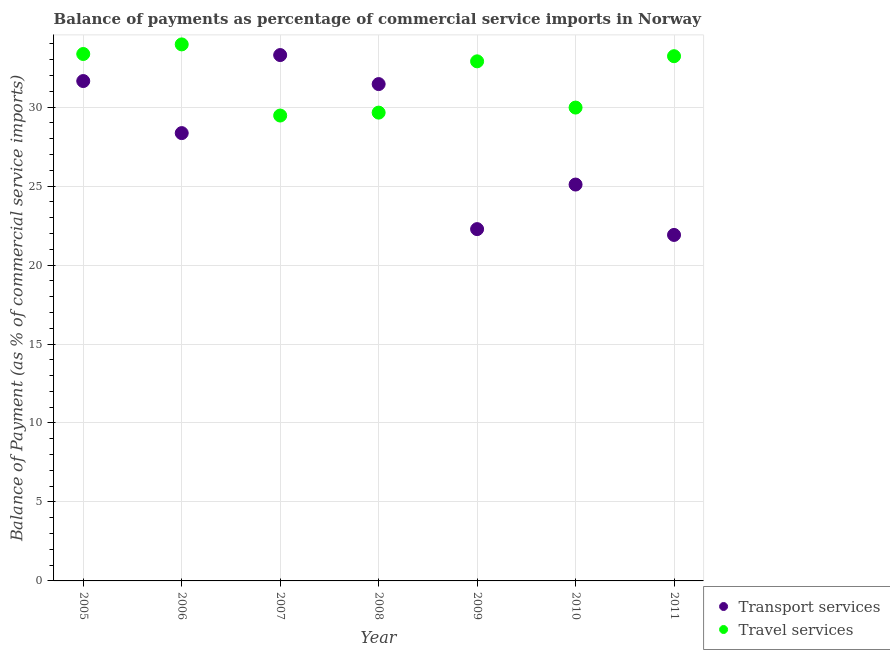How many different coloured dotlines are there?
Provide a succinct answer. 2. What is the balance of payments of transport services in 2008?
Your answer should be compact. 31.46. Across all years, what is the maximum balance of payments of travel services?
Your answer should be compact. 33.97. Across all years, what is the minimum balance of payments of travel services?
Ensure brevity in your answer.  29.47. In which year was the balance of payments of travel services minimum?
Your answer should be compact. 2007. What is the total balance of payments of travel services in the graph?
Your response must be concise. 222.55. What is the difference between the balance of payments of travel services in 2010 and that in 2011?
Ensure brevity in your answer.  -3.25. What is the difference between the balance of payments of travel services in 2010 and the balance of payments of transport services in 2005?
Give a very brief answer. -1.68. What is the average balance of payments of transport services per year?
Offer a terse response. 27.72. In the year 2006, what is the difference between the balance of payments of travel services and balance of payments of transport services?
Offer a very short reply. 5.62. In how many years, is the balance of payments of travel services greater than 12 %?
Provide a succinct answer. 7. What is the ratio of the balance of payments of travel services in 2007 to that in 2008?
Provide a short and direct response. 0.99. What is the difference between the highest and the second highest balance of payments of travel services?
Your response must be concise. 0.61. What is the difference between the highest and the lowest balance of payments of travel services?
Provide a short and direct response. 4.5. In how many years, is the balance of payments of travel services greater than the average balance of payments of travel services taken over all years?
Your answer should be compact. 4. Does the graph contain grids?
Your response must be concise. Yes. How many legend labels are there?
Give a very brief answer. 2. How are the legend labels stacked?
Your response must be concise. Vertical. What is the title of the graph?
Offer a terse response. Balance of payments as percentage of commercial service imports in Norway. Does "Infant" appear as one of the legend labels in the graph?
Ensure brevity in your answer.  No. What is the label or title of the X-axis?
Provide a short and direct response. Year. What is the label or title of the Y-axis?
Your answer should be compact. Balance of Payment (as % of commercial service imports). What is the Balance of Payment (as % of commercial service imports) in Transport services in 2005?
Give a very brief answer. 31.65. What is the Balance of Payment (as % of commercial service imports) of Travel services in 2005?
Make the answer very short. 33.36. What is the Balance of Payment (as % of commercial service imports) of Transport services in 2006?
Ensure brevity in your answer.  28.35. What is the Balance of Payment (as % of commercial service imports) of Travel services in 2006?
Keep it short and to the point. 33.97. What is the Balance of Payment (as % of commercial service imports) in Transport services in 2007?
Keep it short and to the point. 33.3. What is the Balance of Payment (as % of commercial service imports) in Travel services in 2007?
Keep it short and to the point. 29.47. What is the Balance of Payment (as % of commercial service imports) of Transport services in 2008?
Your answer should be very brief. 31.46. What is the Balance of Payment (as % of commercial service imports) of Travel services in 2008?
Offer a very short reply. 29.65. What is the Balance of Payment (as % of commercial service imports) in Transport services in 2009?
Your response must be concise. 22.28. What is the Balance of Payment (as % of commercial service imports) of Travel services in 2009?
Give a very brief answer. 32.9. What is the Balance of Payment (as % of commercial service imports) of Transport services in 2010?
Provide a short and direct response. 25.1. What is the Balance of Payment (as % of commercial service imports) in Travel services in 2010?
Keep it short and to the point. 29.97. What is the Balance of Payment (as % of commercial service imports) of Transport services in 2011?
Offer a terse response. 21.91. What is the Balance of Payment (as % of commercial service imports) of Travel services in 2011?
Your response must be concise. 33.22. Across all years, what is the maximum Balance of Payment (as % of commercial service imports) in Transport services?
Keep it short and to the point. 33.3. Across all years, what is the maximum Balance of Payment (as % of commercial service imports) in Travel services?
Offer a terse response. 33.97. Across all years, what is the minimum Balance of Payment (as % of commercial service imports) of Transport services?
Offer a very short reply. 21.91. Across all years, what is the minimum Balance of Payment (as % of commercial service imports) in Travel services?
Your answer should be very brief. 29.47. What is the total Balance of Payment (as % of commercial service imports) in Transport services in the graph?
Your answer should be very brief. 194.04. What is the total Balance of Payment (as % of commercial service imports) in Travel services in the graph?
Offer a very short reply. 222.55. What is the difference between the Balance of Payment (as % of commercial service imports) in Transport services in 2005 and that in 2006?
Provide a succinct answer. 3.3. What is the difference between the Balance of Payment (as % of commercial service imports) of Travel services in 2005 and that in 2006?
Make the answer very short. -0.61. What is the difference between the Balance of Payment (as % of commercial service imports) of Transport services in 2005 and that in 2007?
Provide a short and direct response. -1.65. What is the difference between the Balance of Payment (as % of commercial service imports) in Travel services in 2005 and that in 2007?
Your answer should be very brief. 3.9. What is the difference between the Balance of Payment (as % of commercial service imports) of Transport services in 2005 and that in 2008?
Your response must be concise. 0.19. What is the difference between the Balance of Payment (as % of commercial service imports) in Travel services in 2005 and that in 2008?
Ensure brevity in your answer.  3.71. What is the difference between the Balance of Payment (as % of commercial service imports) of Transport services in 2005 and that in 2009?
Offer a terse response. 9.38. What is the difference between the Balance of Payment (as % of commercial service imports) of Travel services in 2005 and that in 2009?
Keep it short and to the point. 0.46. What is the difference between the Balance of Payment (as % of commercial service imports) in Transport services in 2005 and that in 2010?
Ensure brevity in your answer.  6.55. What is the difference between the Balance of Payment (as % of commercial service imports) in Travel services in 2005 and that in 2010?
Ensure brevity in your answer.  3.39. What is the difference between the Balance of Payment (as % of commercial service imports) of Transport services in 2005 and that in 2011?
Your answer should be very brief. 9.74. What is the difference between the Balance of Payment (as % of commercial service imports) of Travel services in 2005 and that in 2011?
Provide a short and direct response. 0.14. What is the difference between the Balance of Payment (as % of commercial service imports) in Transport services in 2006 and that in 2007?
Offer a very short reply. -4.94. What is the difference between the Balance of Payment (as % of commercial service imports) in Travel services in 2006 and that in 2007?
Provide a succinct answer. 4.5. What is the difference between the Balance of Payment (as % of commercial service imports) in Transport services in 2006 and that in 2008?
Give a very brief answer. -3.1. What is the difference between the Balance of Payment (as % of commercial service imports) of Travel services in 2006 and that in 2008?
Keep it short and to the point. 4.32. What is the difference between the Balance of Payment (as % of commercial service imports) in Transport services in 2006 and that in 2009?
Keep it short and to the point. 6.08. What is the difference between the Balance of Payment (as % of commercial service imports) in Travel services in 2006 and that in 2009?
Provide a succinct answer. 1.07. What is the difference between the Balance of Payment (as % of commercial service imports) in Transport services in 2006 and that in 2010?
Your answer should be very brief. 3.26. What is the difference between the Balance of Payment (as % of commercial service imports) in Travel services in 2006 and that in 2010?
Provide a short and direct response. 4. What is the difference between the Balance of Payment (as % of commercial service imports) in Transport services in 2006 and that in 2011?
Offer a very short reply. 6.45. What is the difference between the Balance of Payment (as % of commercial service imports) of Travel services in 2006 and that in 2011?
Give a very brief answer. 0.75. What is the difference between the Balance of Payment (as % of commercial service imports) of Transport services in 2007 and that in 2008?
Your response must be concise. 1.84. What is the difference between the Balance of Payment (as % of commercial service imports) of Travel services in 2007 and that in 2008?
Keep it short and to the point. -0.19. What is the difference between the Balance of Payment (as % of commercial service imports) of Transport services in 2007 and that in 2009?
Your answer should be very brief. 11.02. What is the difference between the Balance of Payment (as % of commercial service imports) of Travel services in 2007 and that in 2009?
Offer a very short reply. -3.43. What is the difference between the Balance of Payment (as % of commercial service imports) of Transport services in 2007 and that in 2010?
Offer a terse response. 8.2. What is the difference between the Balance of Payment (as % of commercial service imports) of Travel services in 2007 and that in 2010?
Make the answer very short. -0.5. What is the difference between the Balance of Payment (as % of commercial service imports) of Transport services in 2007 and that in 2011?
Provide a short and direct response. 11.39. What is the difference between the Balance of Payment (as % of commercial service imports) of Travel services in 2007 and that in 2011?
Offer a very short reply. -3.76. What is the difference between the Balance of Payment (as % of commercial service imports) in Transport services in 2008 and that in 2009?
Your answer should be very brief. 9.18. What is the difference between the Balance of Payment (as % of commercial service imports) in Travel services in 2008 and that in 2009?
Ensure brevity in your answer.  -3.25. What is the difference between the Balance of Payment (as % of commercial service imports) of Transport services in 2008 and that in 2010?
Your answer should be compact. 6.36. What is the difference between the Balance of Payment (as % of commercial service imports) of Travel services in 2008 and that in 2010?
Give a very brief answer. -0.32. What is the difference between the Balance of Payment (as % of commercial service imports) of Transport services in 2008 and that in 2011?
Your answer should be very brief. 9.55. What is the difference between the Balance of Payment (as % of commercial service imports) of Travel services in 2008 and that in 2011?
Give a very brief answer. -3.57. What is the difference between the Balance of Payment (as % of commercial service imports) of Transport services in 2009 and that in 2010?
Your response must be concise. -2.82. What is the difference between the Balance of Payment (as % of commercial service imports) in Travel services in 2009 and that in 2010?
Your response must be concise. 2.93. What is the difference between the Balance of Payment (as % of commercial service imports) of Transport services in 2009 and that in 2011?
Ensure brevity in your answer.  0.37. What is the difference between the Balance of Payment (as % of commercial service imports) of Travel services in 2009 and that in 2011?
Ensure brevity in your answer.  -0.33. What is the difference between the Balance of Payment (as % of commercial service imports) of Transport services in 2010 and that in 2011?
Provide a short and direct response. 3.19. What is the difference between the Balance of Payment (as % of commercial service imports) of Travel services in 2010 and that in 2011?
Give a very brief answer. -3.25. What is the difference between the Balance of Payment (as % of commercial service imports) in Transport services in 2005 and the Balance of Payment (as % of commercial service imports) in Travel services in 2006?
Offer a very short reply. -2.32. What is the difference between the Balance of Payment (as % of commercial service imports) in Transport services in 2005 and the Balance of Payment (as % of commercial service imports) in Travel services in 2007?
Make the answer very short. 2.18. What is the difference between the Balance of Payment (as % of commercial service imports) in Transport services in 2005 and the Balance of Payment (as % of commercial service imports) in Travel services in 2008?
Give a very brief answer. 2. What is the difference between the Balance of Payment (as % of commercial service imports) in Transport services in 2005 and the Balance of Payment (as % of commercial service imports) in Travel services in 2009?
Your answer should be very brief. -1.25. What is the difference between the Balance of Payment (as % of commercial service imports) in Transport services in 2005 and the Balance of Payment (as % of commercial service imports) in Travel services in 2010?
Keep it short and to the point. 1.68. What is the difference between the Balance of Payment (as % of commercial service imports) in Transport services in 2005 and the Balance of Payment (as % of commercial service imports) in Travel services in 2011?
Offer a terse response. -1.57. What is the difference between the Balance of Payment (as % of commercial service imports) in Transport services in 2006 and the Balance of Payment (as % of commercial service imports) in Travel services in 2007?
Keep it short and to the point. -1.11. What is the difference between the Balance of Payment (as % of commercial service imports) in Transport services in 2006 and the Balance of Payment (as % of commercial service imports) in Travel services in 2008?
Offer a terse response. -1.3. What is the difference between the Balance of Payment (as % of commercial service imports) in Transport services in 2006 and the Balance of Payment (as % of commercial service imports) in Travel services in 2009?
Your response must be concise. -4.54. What is the difference between the Balance of Payment (as % of commercial service imports) in Transport services in 2006 and the Balance of Payment (as % of commercial service imports) in Travel services in 2010?
Provide a short and direct response. -1.62. What is the difference between the Balance of Payment (as % of commercial service imports) in Transport services in 2006 and the Balance of Payment (as % of commercial service imports) in Travel services in 2011?
Make the answer very short. -4.87. What is the difference between the Balance of Payment (as % of commercial service imports) of Transport services in 2007 and the Balance of Payment (as % of commercial service imports) of Travel services in 2008?
Ensure brevity in your answer.  3.64. What is the difference between the Balance of Payment (as % of commercial service imports) in Transport services in 2007 and the Balance of Payment (as % of commercial service imports) in Travel services in 2009?
Offer a terse response. 0.4. What is the difference between the Balance of Payment (as % of commercial service imports) of Transport services in 2007 and the Balance of Payment (as % of commercial service imports) of Travel services in 2010?
Your response must be concise. 3.32. What is the difference between the Balance of Payment (as % of commercial service imports) in Transport services in 2007 and the Balance of Payment (as % of commercial service imports) in Travel services in 2011?
Make the answer very short. 0.07. What is the difference between the Balance of Payment (as % of commercial service imports) in Transport services in 2008 and the Balance of Payment (as % of commercial service imports) in Travel services in 2009?
Your answer should be compact. -1.44. What is the difference between the Balance of Payment (as % of commercial service imports) in Transport services in 2008 and the Balance of Payment (as % of commercial service imports) in Travel services in 2010?
Provide a short and direct response. 1.49. What is the difference between the Balance of Payment (as % of commercial service imports) in Transport services in 2008 and the Balance of Payment (as % of commercial service imports) in Travel services in 2011?
Provide a succinct answer. -1.77. What is the difference between the Balance of Payment (as % of commercial service imports) in Transport services in 2009 and the Balance of Payment (as % of commercial service imports) in Travel services in 2010?
Give a very brief answer. -7.7. What is the difference between the Balance of Payment (as % of commercial service imports) in Transport services in 2009 and the Balance of Payment (as % of commercial service imports) in Travel services in 2011?
Provide a succinct answer. -10.95. What is the difference between the Balance of Payment (as % of commercial service imports) of Transport services in 2010 and the Balance of Payment (as % of commercial service imports) of Travel services in 2011?
Make the answer very short. -8.13. What is the average Balance of Payment (as % of commercial service imports) of Transport services per year?
Your answer should be compact. 27.72. What is the average Balance of Payment (as % of commercial service imports) of Travel services per year?
Provide a short and direct response. 31.79. In the year 2005, what is the difference between the Balance of Payment (as % of commercial service imports) of Transport services and Balance of Payment (as % of commercial service imports) of Travel services?
Offer a terse response. -1.71. In the year 2006, what is the difference between the Balance of Payment (as % of commercial service imports) in Transport services and Balance of Payment (as % of commercial service imports) in Travel services?
Ensure brevity in your answer.  -5.62. In the year 2007, what is the difference between the Balance of Payment (as % of commercial service imports) of Transport services and Balance of Payment (as % of commercial service imports) of Travel services?
Make the answer very short. 3.83. In the year 2008, what is the difference between the Balance of Payment (as % of commercial service imports) of Transport services and Balance of Payment (as % of commercial service imports) of Travel services?
Ensure brevity in your answer.  1.81. In the year 2009, what is the difference between the Balance of Payment (as % of commercial service imports) in Transport services and Balance of Payment (as % of commercial service imports) in Travel services?
Your answer should be compact. -10.62. In the year 2010, what is the difference between the Balance of Payment (as % of commercial service imports) in Transport services and Balance of Payment (as % of commercial service imports) in Travel services?
Make the answer very short. -4.87. In the year 2011, what is the difference between the Balance of Payment (as % of commercial service imports) of Transport services and Balance of Payment (as % of commercial service imports) of Travel services?
Offer a terse response. -11.32. What is the ratio of the Balance of Payment (as % of commercial service imports) of Transport services in 2005 to that in 2006?
Offer a terse response. 1.12. What is the ratio of the Balance of Payment (as % of commercial service imports) of Travel services in 2005 to that in 2006?
Give a very brief answer. 0.98. What is the ratio of the Balance of Payment (as % of commercial service imports) in Transport services in 2005 to that in 2007?
Your response must be concise. 0.95. What is the ratio of the Balance of Payment (as % of commercial service imports) in Travel services in 2005 to that in 2007?
Your response must be concise. 1.13. What is the ratio of the Balance of Payment (as % of commercial service imports) in Travel services in 2005 to that in 2008?
Make the answer very short. 1.13. What is the ratio of the Balance of Payment (as % of commercial service imports) of Transport services in 2005 to that in 2009?
Ensure brevity in your answer.  1.42. What is the ratio of the Balance of Payment (as % of commercial service imports) of Travel services in 2005 to that in 2009?
Make the answer very short. 1.01. What is the ratio of the Balance of Payment (as % of commercial service imports) in Transport services in 2005 to that in 2010?
Your answer should be compact. 1.26. What is the ratio of the Balance of Payment (as % of commercial service imports) of Travel services in 2005 to that in 2010?
Make the answer very short. 1.11. What is the ratio of the Balance of Payment (as % of commercial service imports) in Transport services in 2005 to that in 2011?
Ensure brevity in your answer.  1.44. What is the ratio of the Balance of Payment (as % of commercial service imports) of Transport services in 2006 to that in 2007?
Your response must be concise. 0.85. What is the ratio of the Balance of Payment (as % of commercial service imports) in Travel services in 2006 to that in 2007?
Give a very brief answer. 1.15. What is the ratio of the Balance of Payment (as % of commercial service imports) of Transport services in 2006 to that in 2008?
Offer a terse response. 0.9. What is the ratio of the Balance of Payment (as % of commercial service imports) in Travel services in 2006 to that in 2008?
Give a very brief answer. 1.15. What is the ratio of the Balance of Payment (as % of commercial service imports) in Transport services in 2006 to that in 2009?
Make the answer very short. 1.27. What is the ratio of the Balance of Payment (as % of commercial service imports) in Travel services in 2006 to that in 2009?
Provide a short and direct response. 1.03. What is the ratio of the Balance of Payment (as % of commercial service imports) in Transport services in 2006 to that in 2010?
Keep it short and to the point. 1.13. What is the ratio of the Balance of Payment (as % of commercial service imports) in Travel services in 2006 to that in 2010?
Keep it short and to the point. 1.13. What is the ratio of the Balance of Payment (as % of commercial service imports) of Transport services in 2006 to that in 2011?
Keep it short and to the point. 1.29. What is the ratio of the Balance of Payment (as % of commercial service imports) in Travel services in 2006 to that in 2011?
Make the answer very short. 1.02. What is the ratio of the Balance of Payment (as % of commercial service imports) of Transport services in 2007 to that in 2008?
Your answer should be very brief. 1.06. What is the ratio of the Balance of Payment (as % of commercial service imports) of Travel services in 2007 to that in 2008?
Make the answer very short. 0.99. What is the ratio of the Balance of Payment (as % of commercial service imports) in Transport services in 2007 to that in 2009?
Your answer should be very brief. 1.49. What is the ratio of the Balance of Payment (as % of commercial service imports) in Travel services in 2007 to that in 2009?
Provide a succinct answer. 0.9. What is the ratio of the Balance of Payment (as % of commercial service imports) in Transport services in 2007 to that in 2010?
Offer a terse response. 1.33. What is the ratio of the Balance of Payment (as % of commercial service imports) of Travel services in 2007 to that in 2010?
Provide a succinct answer. 0.98. What is the ratio of the Balance of Payment (as % of commercial service imports) in Transport services in 2007 to that in 2011?
Keep it short and to the point. 1.52. What is the ratio of the Balance of Payment (as % of commercial service imports) in Travel services in 2007 to that in 2011?
Your answer should be very brief. 0.89. What is the ratio of the Balance of Payment (as % of commercial service imports) in Transport services in 2008 to that in 2009?
Your answer should be compact. 1.41. What is the ratio of the Balance of Payment (as % of commercial service imports) of Travel services in 2008 to that in 2009?
Your answer should be very brief. 0.9. What is the ratio of the Balance of Payment (as % of commercial service imports) of Transport services in 2008 to that in 2010?
Make the answer very short. 1.25. What is the ratio of the Balance of Payment (as % of commercial service imports) of Travel services in 2008 to that in 2010?
Ensure brevity in your answer.  0.99. What is the ratio of the Balance of Payment (as % of commercial service imports) in Transport services in 2008 to that in 2011?
Offer a very short reply. 1.44. What is the ratio of the Balance of Payment (as % of commercial service imports) in Travel services in 2008 to that in 2011?
Your answer should be compact. 0.89. What is the ratio of the Balance of Payment (as % of commercial service imports) in Transport services in 2009 to that in 2010?
Your answer should be compact. 0.89. What is the ratio of the Balance of Payment (as % of commercial service imports) in Travel services in 2009 to that in 2010?
Your answer should be very brief. 1.1. What is the ratio of the Balance of Payment (as % of commercial service imports) of Transport services in 2009 to that in 2011?
Your answer should be compact. 1.02. What is the ratio of the Balance of Payment (as % of commercial service imports) in Travel services in 2009 to that in 2011?
Your answer should be compact. 0.99. What is the ratio of the Balance of Payment (as % of commercial service imports) of Transport services in 2010 to that in 2011?
Make the answer very short. 1.15. What is the ratio of the Balance of Payment (as % of commercial service imports) of Travel services in 2010 to that in 2011?
Your response must be concise. 0.9. What is the difference between the highest and the second highest Balance of Payment (as % of commercial service imports) of Transport services?
Offer a very short reply. 1.65. What is the difference between the highest and the second highest Balance of Payment (as % of commercial service imports) of Travel services?
Keep it short and to the point. 0.61. What is the difference between the highest and the lowest Balance of Payment (as % of commercial service imports) of Transport services?
Give a very brief answer. 11.39. What is the difference between the highest and the lowest Balance of Payment (as % of commercial service imports) in Travel services?
Your answer should be very brief. 4.5. 